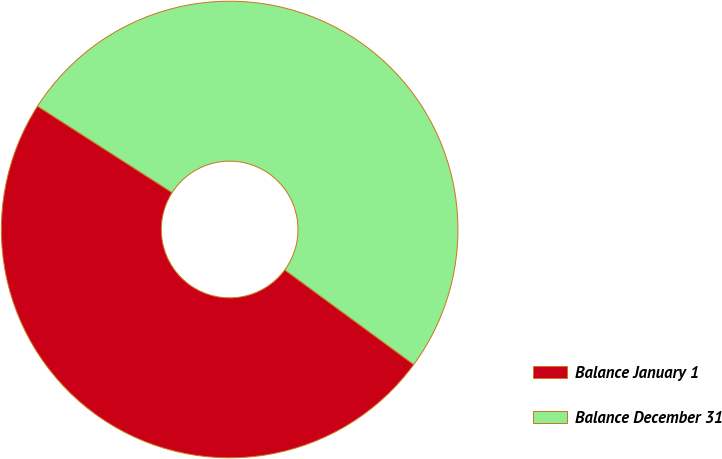<chart> <loc_0><loc_0><loc_500><loc_500><pie_chart><fcel>Balance January 1<fcel>Balance December 31<nl><fcel>49.01%<fcel>50.99%<nl></chart> 